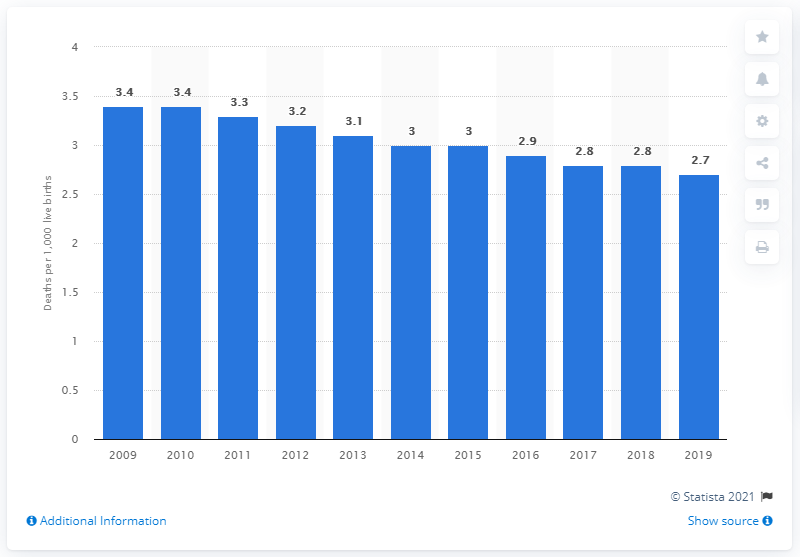Give some essential details in this illustration. In 2019, the infant mortality rate in Italy was 2.7 per 1,000 live births. 